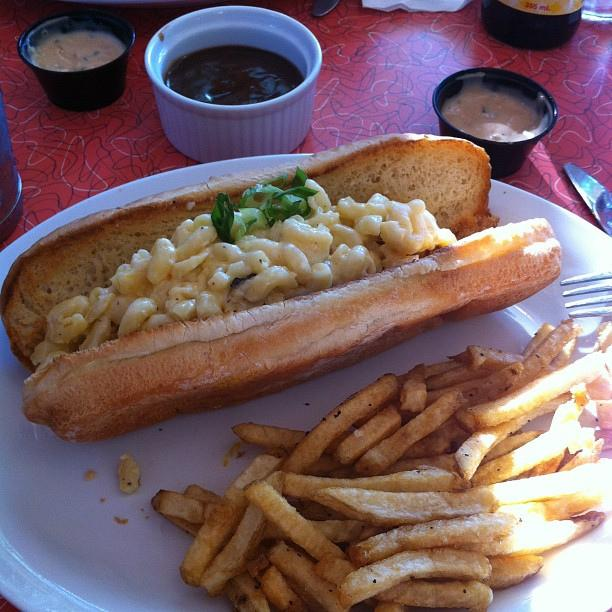What would usually be where the pasta is? hot dog 